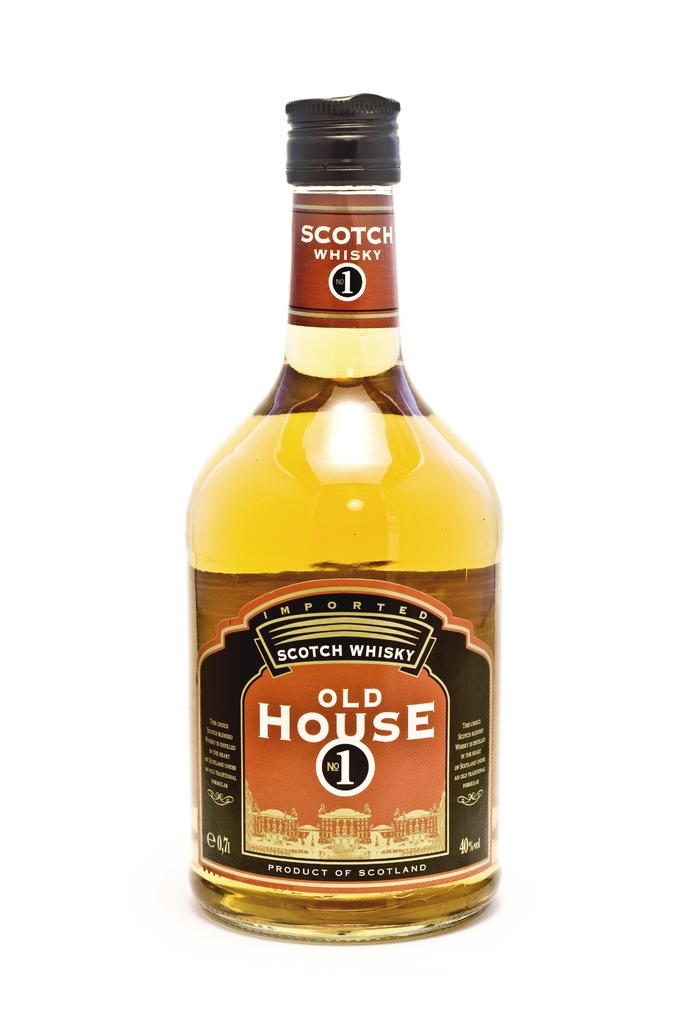What is in the wine bottle that is visible in the image? There is a wine bottle in the image. What information can be gathered from the label on the wine bottle? The label indicates that the wine bottle contains whisky. Where is the seat located in the image? There is no seat present in the image. What type of rake is being used to harvest the grapes for the whisky in the image? There is no rake or grape harvesting depicted in the image, and the whisky is already contained in the labeled wine bottle. 